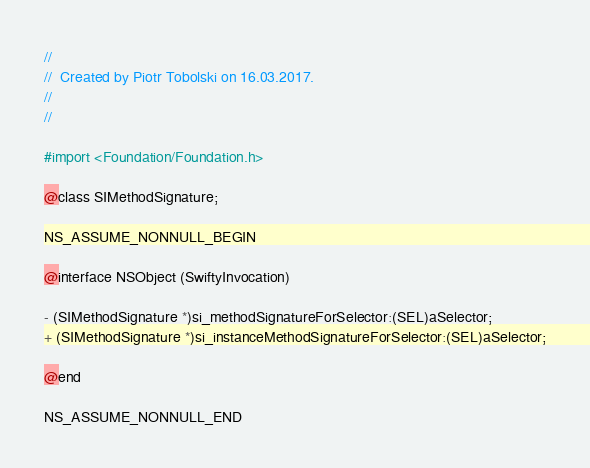Convert code to text. <code><loc_0><loc_0><loc_500><loc_500><_C_>//
//  Created by Piotr Tobolski on 16.03.2017.
//
//

#import <Foundation/Foundation.h>

@class SIMethodSignature;

NS_ASSUME_NONNULL_BEGIN

@interface NSObject (SwiftyInvocation)

- (SIMethodSignature *)si_methodSignatureForSelector:(SEL)aSelector;
+ (SIMethodSignature *)si_instanceMethodSignatureForSelector:(SEL)aSelector;

@end

NS_ASSUME_NONNULL_END
</code> 